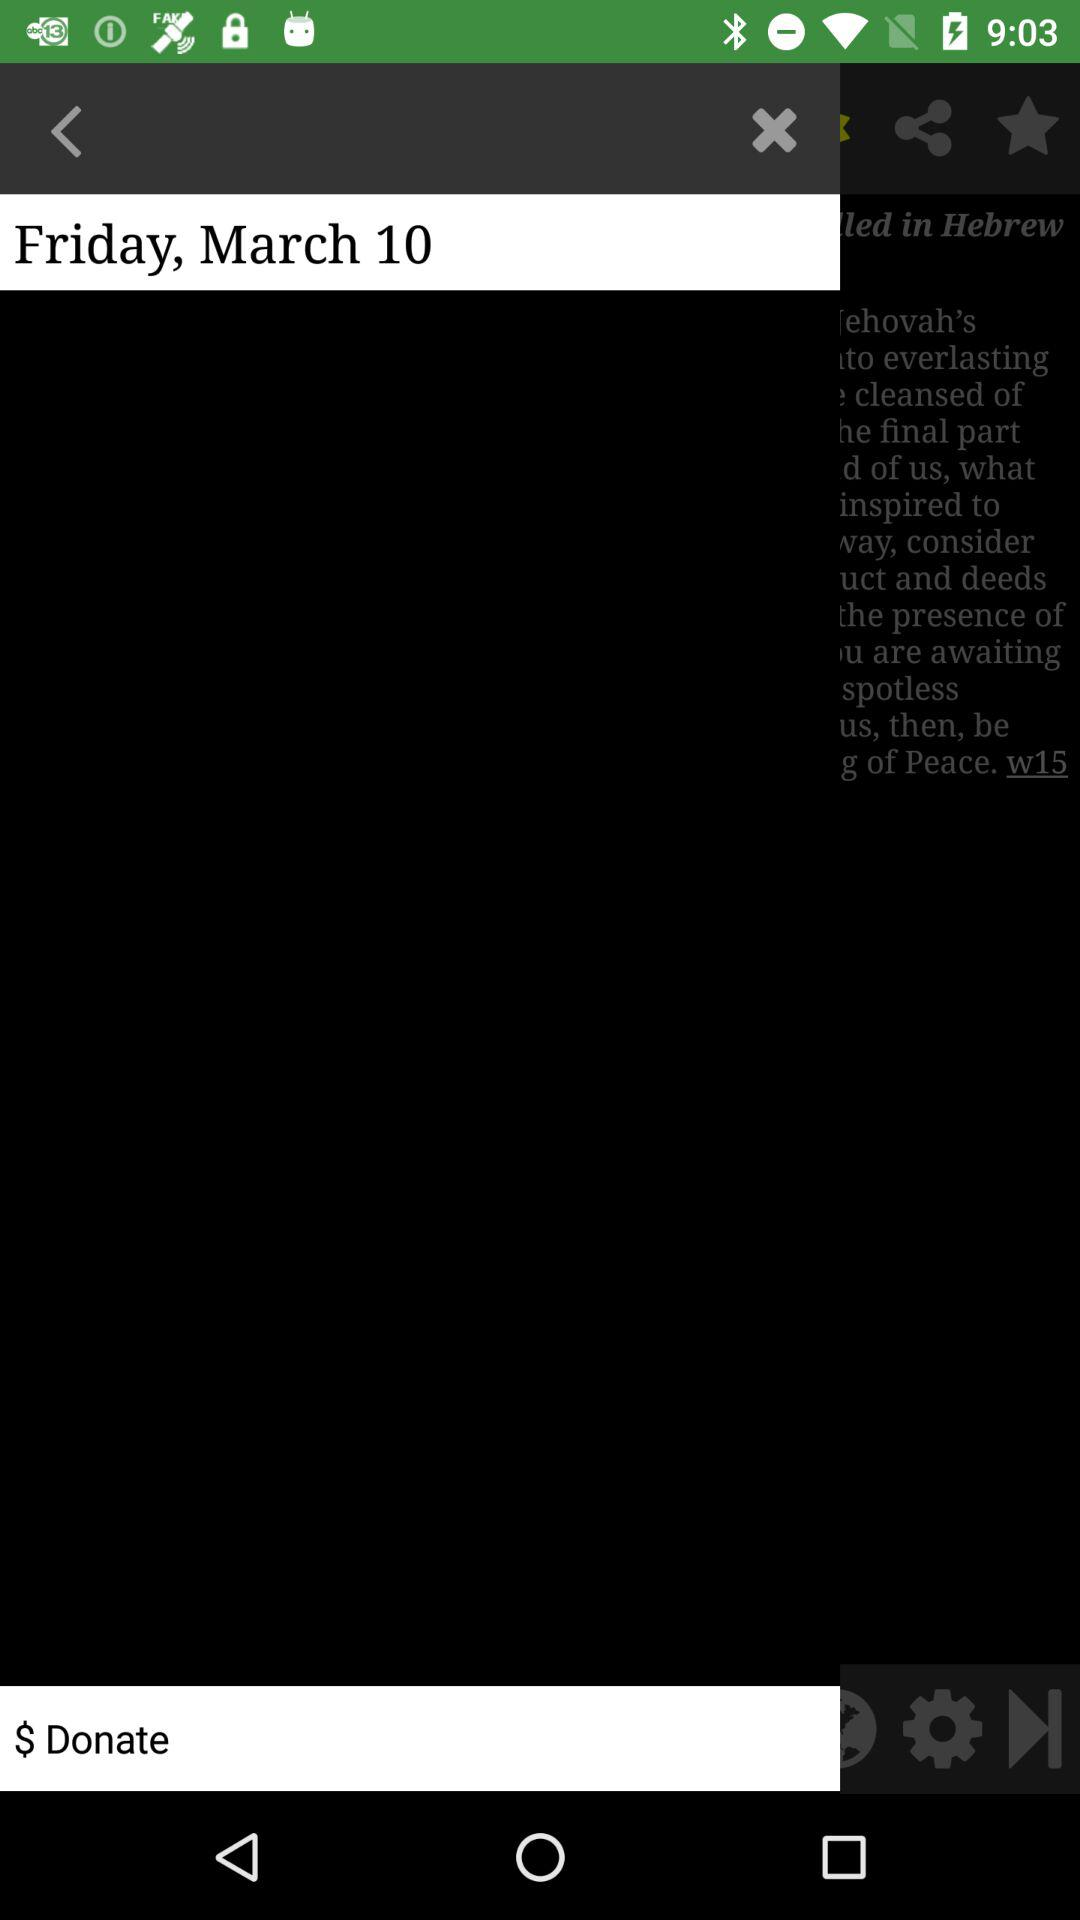What is the mentioned date? The mentioned date is Friday, March 10. 